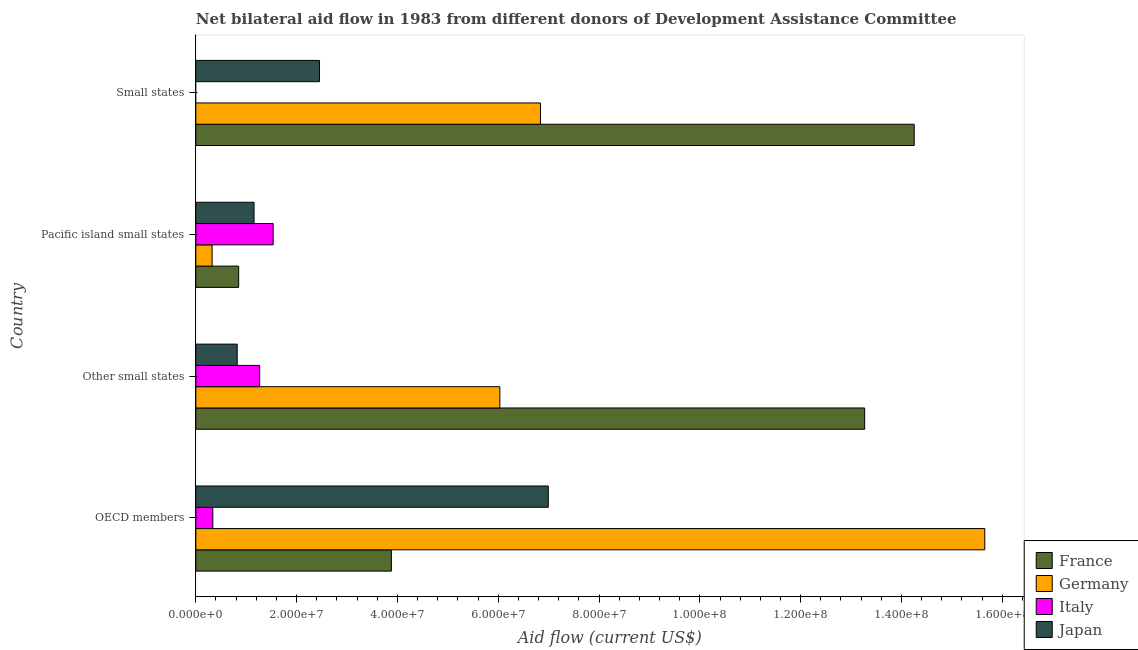How many different coloured bars are there?
Ensure brevity in your answer.  4. How many bars are there on the 4th tick from the bottom?
Keep it short and to the point. 3. What is the label of the 1st group of bars from the top?
Make the answer very short. Small states. What is the amount of aid given by germany in Other small states?
Your answer should be very brief. 6.03e+07. Across all countries, what is the maximum amount of aid given by germany?
Give a very brief answer. 1.57e+08. Across all countries, what is the minimum amount of aid given by france?
Offer a terse response. 8.50e+06. In which country was the amount of aid given by japan maximum?
Your answer should be very brief. OECD members. What is the total amount of aid given by japan in the graph?
Your response must be concise. 1.14e+08. What is the difference between the amount of aid given by france in Pacific island small states and that in Small states?
Your response must be concise. -1.34e+08. What is the difference between the amount of aid given by japan in Pacific island small states and the amount of aid given by italy in Other small states?
Your answer should be very brief. -1.12e+06. What is the average amount of aid given by japan per country?
Your answer should be very brief. 2.86e+07. What is the difference between the amount of aid given by france and amount of aid given by germany in OECD members?
Your response must be concise. -1.18e+08. In how many countries, is the amount of aid given by germany greater than 20000000 US$?
Your answer should be compact. 3. What is the ratio of the amount of aid given by germany in OECD members to that in Pacific island small states?
Offer a very short reply. 48.46. What is the difference between the highest and the second highest amount of aid given by france?
Your response must be concise. 9.83e+06. What is the difference between the highest and the lowest amount of aid given by italy?
Keep it short and to the point. 1.54e+07. In how many countries, is the amount of aid given by italy greater than the average amount of aid given by italy taken over all countries?
Your answer should be very brief. 2. Is the sum of the amount of aid given by japan in Pacific island small states and Small states greater than the maximum amount of aid given by france across all countries?
Offer a terse response. No. Are all the bars in the graph horizontal?
Ensure brevity in your answer.  Yes. What is the difference between two consecutive major ticks on the X-axis?
Give a very brief answer. 2.00e+07. Where does the legend appear in the graph?
Ensure brevity in your answer.  Bottom right. What is the title of the graph?
Give a very brief answer. Net bilateral aid flow in 1983 from different donors of Development Assistance Committee. Does "Other Minerals" appear as one of the legend labels in the graph?
Provide a short and direct response. No. What is the label or title of the X-axis?
Make the answer very short. Aid flow (current US$). What is the Aid flow (current US$) of France in OECD members?
Offer a very short reply. 3.88e+07. What is the Aid flow (current US$) in Germany in OECD members?
Make the answer very short. 1.57e+08. What is the Aid flow (current US$) of Italy in OECD members?
Your answer should be compact. 3.37e+06. What is the Aid flow (current US$) in Japan in OECD members?
Your response must be concise. 6.99e+07. What is the Aid flow (current US$) of France in Other small states?
Your response must be concise. 1.33e+08. What is the Aid flow (current US$) of Germany in Other small states?
Provide a succinct answer. 6.03e+07. What is the Aid flow (current US$) of Italy in Other small states?
Make the answer very short. 1.27e+07. What is the Aid flow (current US$) in Japan in Other small states?
Provide a succinct answer. 8.21e+06. What is the Aid flow (current US$) in France in Pacific island small states?
Give a very brief answer. 8.50e+06. What is the Aid flow (current US$) of Germany in Pacific island small states?
Your answer should be very brief. 3.23e+06. What is the Aid flow (current US$) in Italy in Pacific island small states?
Ensure brevity in your answer.  1.54e+07. What is the Aid flow (current US$) in Japan in Pacific island small states?
Ensure brevity in your answer.  1.16e+07. What is the Aid flow (current US$) of France in Small states?
Make the answer very short. 1.43e+08. What is the Aid flow (current US$) of Germany in Small states?
Make the answer very short. 6.84e+07. What is the Aid flow (current US$) in Japan in Small states?
Offer a terse response. 2.45e+07. Across all countries, what is the maximum Aid flow (current US$) in France?
Ensure brevity in your answer.  1.43e+08. Across all countries, what is the maximum Aid flow (current US$) in Germany?
Make the answer very short. 1.57e+08. Across all countries, what is the maximum Aid flow (current US$) of Italy?
Keep it short and to the point. 1.54e+07. Across all countries, what is the maximum Aid flow (current US$) of Japan?
Ensure brevity in your answer.  6.99e+07. Across all countries, what is the minimum Aid flow (current US$) of France?
Give a very brief answer. 8.50e+06. Across all countries, what is the minimum Aid flow (current US$) in Germany?
Keep it short and to the point. 3.23e+06. Across all countries, what is the minimum Aid flow (current US$) in Italy?
Give a very brief answer. 0. Across all countries, what is the minimum Aid flow (current US$) of Japan?
Your answer should be compact. 8.21e+06. What is the total Aid flow (current US$) of France in the graph?
Provide a succinct answer. 3.23e+08. What is the total Aid flow (current US$) of Germany in the graph?
Provide a short and direct response. 2.88e+08. What is the total Aid flow (current US$) in Italy in the graph?
Provide a short and direct response. 3.14e+07. What is the total Aid flow (current US$) of Japan in the graph?
Keep it short and to the point. 1.14e+08. What is the difference between the Aid flow (current US$) of France in OECD members and that in Other small states?
Your response must be concise. -9.39e+07. What is the difference between the Aid flow (current US$) in Germany in OECD members and that in Other small states?
Offer a very short reply. 9.62e+07. What is the difference between the Aid flow (current US$) of Italy in OECD members and that in Other small states?
Provide a succinct answer. -9.30e+06. What is the difference between the Aid flow (current US$) in Japan in OECD members and that in Other small states?
Your answer should be compact. 6.17e+07. What is the difference between the Aid flow (current US$) in France in OECD members and that in Pacific island small states?
Provide a short and direct response. 3.03e+07. What is the difference between the Aid flow (current US$) of Germany in OECD members and that in Pacific island small states?
Offer a very short reply. 1.53e+08. What is the difference between the Aid flow (current US$) in Italy in OECD members and that in Pacific island small states?
Offer a very short reply. -1.20e+07. What is the difference between the Aid flow (current US$) in Japan in OECD members and that in Pacific island small states?
Your answer should be very brief. 5.84e+07. What is the difference between the Aid flow (current US$) of France in OECD members and that in Small states?
Provide a succinct answer. -1.04e+08. What is the difference between the Aid flow (current US$) in Germany in OECD members and that in Small states?
Provide a short and direct response. 8.82e+07. What is the difference between the Aid flow (current US$) in Japan in OECD members and that in Small states?
Your response must be concise. 4.54e+07. What is the difference between the Aid flow (current US$) in France in Other small states and that in Pacific island small states?
Give a very brief answer. 1.24e+08. What is the difference between the Aid flow (current US$) in Germany in Other small states and that in Pacific island small states?
Offer a very short reply. 5.71e+07. What is the difference between the Aid flow (current US$) in Italy in Other small states and that in Pacific island small states?
Ensure brevity in your answer.  -2.68e+06. What is the difference between the Aid flow (current US$) of Japan in Other small states and that in Pacific island small states?
Offer a very short reply. -3.34e+06. What is the difference between the Aid flow (current US$) in France in Other small states and that in Small states?
Offer a very short reply. -9.83e+06. What is the difference between the Aid flow (current US$) in Germany in Other small states and that in Small states?
Provide a short and direct response. -8.06e+06. What is the difference between the Aid flow (current US$) of Japan in Other small states and that in Small states?
Your response must be concise. -1.63e+07. What is the difference between the Aid flow (current US$) in France in Pacific island small states and that in Small states?
Your answer should be compact. -1.34e+08. What is the difference between the Aid flow (current US$) of Germany in Pacific island small states and that in Small states?
Your answer should be very brief. -6.52e+07. What is the difference between the Aid flow (current US$) in Japan in Pacific island small states and that in Small states?
Provide a short and direct response. -1.30e+07. What is the difference between the Aid flow (current US$) of France in OECD members and the Aid flow (current US$) of Germany in Other small states?
Provide a succinct answer. -2.15e+07. What is the difference between the Aid flow (current US$) in France in OECD members and the Aid flow (current US$) in Italy in Other small states?
Your answer should be compact. 2.61e+07. What is the difference between the Aid flow (current US$) of France in OECD members and the Aid flow (current US$) of Japan in Other small states?
Make the answer very short. 3.06e+07. What is the difference between the Aid flow (current US$) of Germany in OECD members and the Aid flow (current US$) of Italy in Other small states?
Make the answer very short. 1.44e+08. What is the difference between the Aid flow (current US$) of Germany in OECD members and the Aid flow (current US$) of Japan in Other small states?
Give a very brief answer. 1.48e+08. What is the difference between the Aid flow (current US$) in Italy in OECD members and the Aid flow (current US$) in Japan in Other small states?
Your response must be concise. -4.84e+06. What is the difference between the Aid flow (current US$) in France in OECD members and the Aid flow (current US$) in Germany in Pacific island small states?
Make the answer very short. 3.56e+07. What is the difference between the Aid flow (current US$) in France in OECD members and the Aid flow (current US$) in Italy in Pacific island small states?
Offer a terse response. 2.34e+07. What is the difference between the Aid flow (current US$) of France in OECD members and the Aid flow (current US$) of Japan in Pacific island small states?
Keep it short and to the point. 2.72e+07. What is the difference between the Aid flow (current US$) of Germany in OECD members and the Aid flow (current US$) of Italy in Pacific island small states?
Give a very brief answer. 1.41e+08. What is the difference between the Aid flow (current US$) in Germany in OECD members and the Aid flow (current US$) in Japan in Pacific island small states?
Make the answer very short. 1.45e+08. What is the difference between the Aid flow (current US$) of Italy in OECD members and the Aid flow (current US$) of Japan in Pacific island small states?
Ensure brevity in your answer.  -8.18e+06. What is the difference between the Aid flow (current US$) of France in OECD members and the Aid flow (current US$) of Germany in Small states?
Offer a terse response. -2.96e+07. What is the difference between the Aid flow (current US$) of France in OECD members and the Aid flow (current US$) of Japan in Small states?
Give a very brief answer. 1.43e+07. What is the difference between the Aid flow (current US$) of Germany in OECD members and the Aid flow (current US$) of Japan in Small states?
Offer a terse response. 1.32e+08. What is the difference between the Aid flow (current US$) in Italy in OECD members and the Aid flow (current US$) in Japan in Small states?
Your answer should be compact. -2.12e+07. What is the difference between the Aid flow (current US$) of France in Other small states and the Aid flow (current US$) of Germany in Pacific island small states?
Provide a short and direct response. 1.29e+08. What is the difference between the Aid flow (current US$) of France in Other small states and the Aid flow (current US$) of Italy in Pacific island small states?
Make the answer very short. 1.17e+08. What is the difference between the Aid flow (current US$) in France in Other small states and the Aid flow (current US$) in Japan in Pacific island small states?
Your response must be concise. 1.21e+08. What is the difference between the Aid flow (current US$) in Germany in Other small states and the Aid flow (current US$) in Italy in Pacific island small states?
Your answer should be very brief. 4.50e+07. What is the difference between the Aid flow (current US$) of Germany in Other small states and the Aid flow (current US$) of Japan in Pacific island small states?
Make the answer very short. 4.88e+07. What is the difference between the Aid flow (current US$) of Italy in Other small states and the Aid flow (current US$) of Japan in Pacific island small states?
Your response must be concise. 1.12e+06. What is the difference between the Aid flow (current US$) in France in Other small states and the Aid flow (current US$) in Germany in Small states?
Give a very brief answer. 6.43e+07. What is the difference between the Aid flow (current US$) in France in Other small states and the Aid flow (current US$) in Japan in Small states?
Ensure brevity in your answer.  1.08e+08. What is the difference between the Aid flow (current US$) in Germany in Other small states and the Aid flow (current US$) in Japan in Small states?
Offer a very short reply. 3.58e+07. What is the difference between the Aid flow (current US$) in Italy in Other small states and the Aid flow (current US$) in Japan in Small states?
Your answer should be very brief. -1.19e+07. What is the difference between the Aid flow (current US$) of France in Pacific island small states and the Aid flow (current US$) of Germany in Small states?
Keep it short and to the point. -5.99e+07. What is the difference between the Aid flow (current US$) in France in Pacific island small states and the Aid flow (current US$) in Japan in Small states?
Offer a terse response. -1.60e+07. What is the difference between the Aid flow (current US$) of Germany in Pacific island small states and the Aid flow (current US$) of Japan in Small states?
Provide a succinct answer. -2.13e+07. What is the difference between the Aid flow (current US$) in Italy in Pacific island small states and the Aid flow (current US$) in Japan in Small states?
Offer a terse response. -9.19e+06. What is the average Aid flow (current US$) of France per country?
Keep it short and to the point. 8.06e+07. What is the average Aid flow (current US$) of Germany per country?
Provide a short and direct response. 7.21e+07. What is the average Aid flow (current US$) of Italy per country?
Give a very brief answer. 7.85e+06. What is the average Aid flow (current US$) of Japan per country?
Give a very brief answer. 2.86e+07. What is the difference between the Aid flow (current US$) in France and Aid flow (current US$) in Germany in OECD members?
Ensure brevity in your answer.  -1.18e+08. What is the difference between the Aid flow (current US$) of France and Aid flow (current US$) of Italy in OECD members?
Make the answer very short. 3.54e+07. What is the difference between the Aid flow (current US$) in France and Aid flow (current US$) in Japan in OECD members?
Offer a very short reply. -3.11e+07. What is the difference between the Aid flow (current US$) of Germany and Aid flow (current US$) of Italy in OECD members?
Offer a terse response. 1.53e+08. What is the difference between the Aid flow (current US$) of Germany and Aid flow (current US$) of Japan in OECD members?
Keep it short and to the point. 8.66e+07. What is the difference between the Aid flow (current US$) of Italy and Aid flow (current US$) of Japan in OECD members?
Your answer should be very brief. -6.66e+07. What is the difference between the Aid flow (current US$) in France and Aid flow (current US$) in Germany in Other small states?
Keep it short and to the point. 7.24e+07. What is the difference between the Aid flow (current US$) in France and Aid flow (current US$) in Italy in Other small states?
Offer a terse response. 1.20e+08. What is the difference between the Aid flow (current US$) in France and Aid flow (current US$) in Japan in Other small states?
Ensure brevity in your answer.  1.24e+08. What is the difference between the Aid flow (current US$) of Germany and Aid flow (current US$) of Italy in Other small states?
Your answer should be very brief. 4.76e+07. What is the difference between the Aid flow (current US$) in Germany and Aid flow (current US$) in Japan in Other small states?
Make the answer very short. 5.21e+07. What is the difference between the Aid flow (current US$) in Italy and Aid flow (current US$) in Japan in Other small states?
Your response must be concise. 4.46e+06. What is the difference between the Aid flow (current US$) of France and Aid flow (current US$) of Germany in Pacific island small states?
Provide a succinct answer. 5.27e+06. What is the difference between the Aid flow (current US$) of France and Aid flow (current US$) of Italy in Pacific island small states?
Offer a terse response. -6.85e+06. What is the difference between the Aid flow (current US$) in France and Aid flow (current US$) in Japan in Pacific island small states?
Keep it short and to the point. -3.05e+06. What is the difference between the Aid flow (current US$) in Germany and Aid flow (current US$) in Italy in Pacific island small states?
Offer a terse response. -1.21e+07. What is the difference between the Aid flow (current US$) of Germany and Aid flow (current US$) of Japan in Pacific island small states?
Make the answer very short. -8.32e+06. What is the difference between the Aid flow (current US$) of Italy and Aid flow (current US$) of Japan in Pacific island small states?
Provide a short and direct response. 3.80e+06. What is the difference between the Aid flow (current US$) of France and Aid flow (current US$) of Germany in Small states?
Offer a very short reply. 7.42e+07. What is the difference between the Aid flow (current US$) of France and Aid flow (current US$) of Japan in Small states?
Make the answer very short. 1.18e+08. What is the difference between the Aid flow (current US$) in Germany and Aid flow (current US$) in Japan in Small states?
Keep it short and to the point. 4.38e+07. What is the ratio of the Aid flow (current US$) of France in OECD members to that in Other small states?
Ensure brevity in your answer.  0.29. What is the ratio of the Aid flow (current US$) in Germany in OECD members to that in Other small states?
Give a very brief answer. 2.6. What is the ratio of the Aid flow (current US$) in Italy in OECD members to that in Other small states?
Give a very brief answer. 0.27. What is the ratio of the Aid flow (current US$) in Japan in OECD members to that in Other small states?
Keep it short and to the point. 8.52. What is the ratio of the Aid flow (current US$) in France in OECD members to that in Pacific island small states?
Offer a very short reply. 4.56. What is the ratio of the Aid flow (current US$) of Germany in OECD members to that in Pacific island small states?
Your response must be concise. 48.46. What is the ratio of the Aid flow (current US$) of Italy in OECD members to that in Pacific island small states?
Ensure brevity in your answer.  0.22. What is the ratio of the Aid flow (current US$) in Japan in OECD members to that in Pacific island small states?
Provide a succinct answer. 6.05. What is the ratio of the Aid flow (current US$) of France in OECD members to that in Small states?
Keep it short and to the point. 0.27. What is the ratio of the Aid flow (current US$) of Germany in OECD members to that in Small states?
Provide a succinct answer. 2.29. What is the ratio of the Aid flow (current US$) in Japan in OECD members to that in Small states?
Provide a succinct answer. 2.85. What is the ratio of the Aid flow (current US$) in France in Other small states to that in Pacific island small states?
Ensure brevity in your answer.  15.61. What is the ratio of the Aid flow (current US$) in Germany in Other small states to that in Pacific island small states?
Ensure brevity in your answer.  18.67. What is the ratio of the Aid flow (current US$) in Italy in Other small states to that in Pacific island small states?
Offer a very short reply. 0.83. What is the ratio of the Aid flow (current US$) in Japan in Other small states to that in Pacific island small states?
Offer a terse response. 0.71. What is the ratio of the Aid flow (current US$) of Germany in Other small states to that in Small states?
Your response must be concise. 0.88. What is the ratio of the Aid flow (current US$) in Japan in Other small states to that in Small states?
Provide a short and direct response. 0.33. What is the ratio of the Aid flow (current US$) of France in Pacific island small states to that in Small states?
Your response must be concise. 0.06. What is the ratio of the Aid flow (current US$) in Germany in Pacific island small states to that in Small states?
Give a very brief answer. 0.05. What is the ratio of the Aid flow (current US$) in Japan in Pacific island small states to that in Small states?
Offer a terse response. 0.47. What is the difference between the highest and the second highest Aid flow (current US$) in France?
Offer a very short reply. 9.83e+06. What is the difference between the highest and the second highest Aid flow (current US$) in Germany?
Provide a succinct answer. 8.82e+07. What is the difference between the highest and the second highest Aid flow (current US$) of Italy?
Offer a terse response. 2.68e+06. What is the difference between the highest and the second highest Aid flow (current US$) of Japan?
Ensure brevity in your answer.  4.54e+07. What is the difference between the highest and the lowest Aid flow (current US$) of France?
Provide a succinct answer. 1.34e+08. What is the difference between the highest and the lowest Aid flow (current US$) of Germany?
Your response must be concise. 1.53e+08. What is the difference between the highest and the lowest Aid flow (current US$) of Italy?
Make the answer very short. 1.54e+07. What is the difference between the highest and the lowest Aid flow (current US$) in Japan?
Your response must be concise. 6.17e+07. 